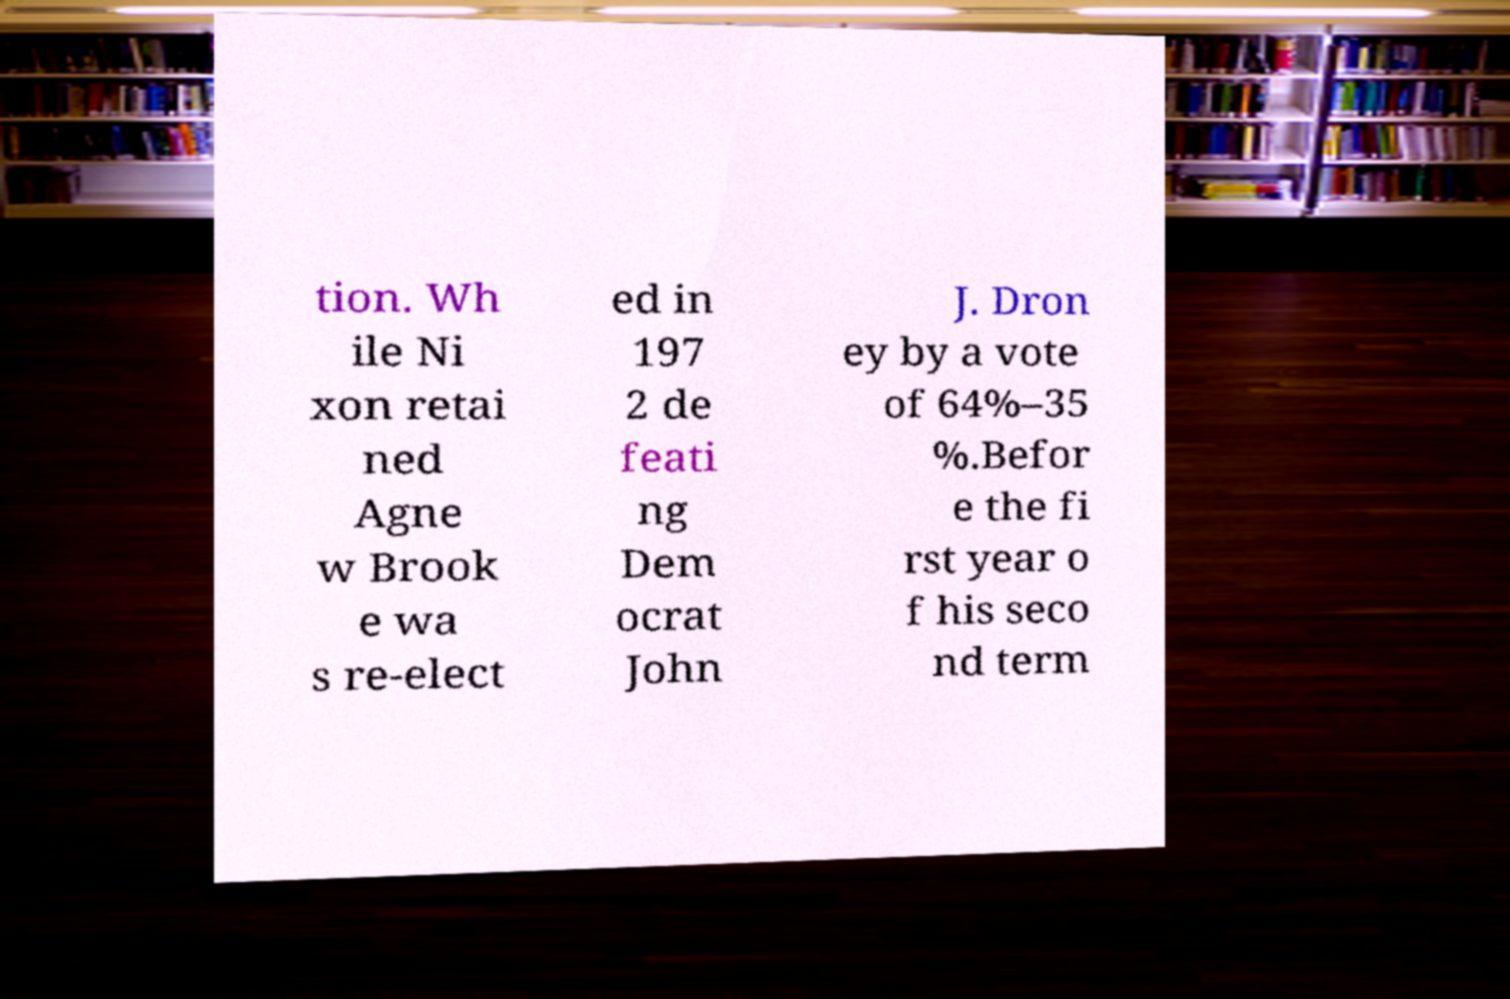What messages or text are displayed in this image? I need them in a readable, typed format. tion. Wh ile Ni xon retai ned Agne w Brook e wa s re-elect ed in 197 2 de feati ng Dem ocrat John J. Dron ey by a vote of 64%–35 %.Befor e the fi rst year o f his seco nd term 